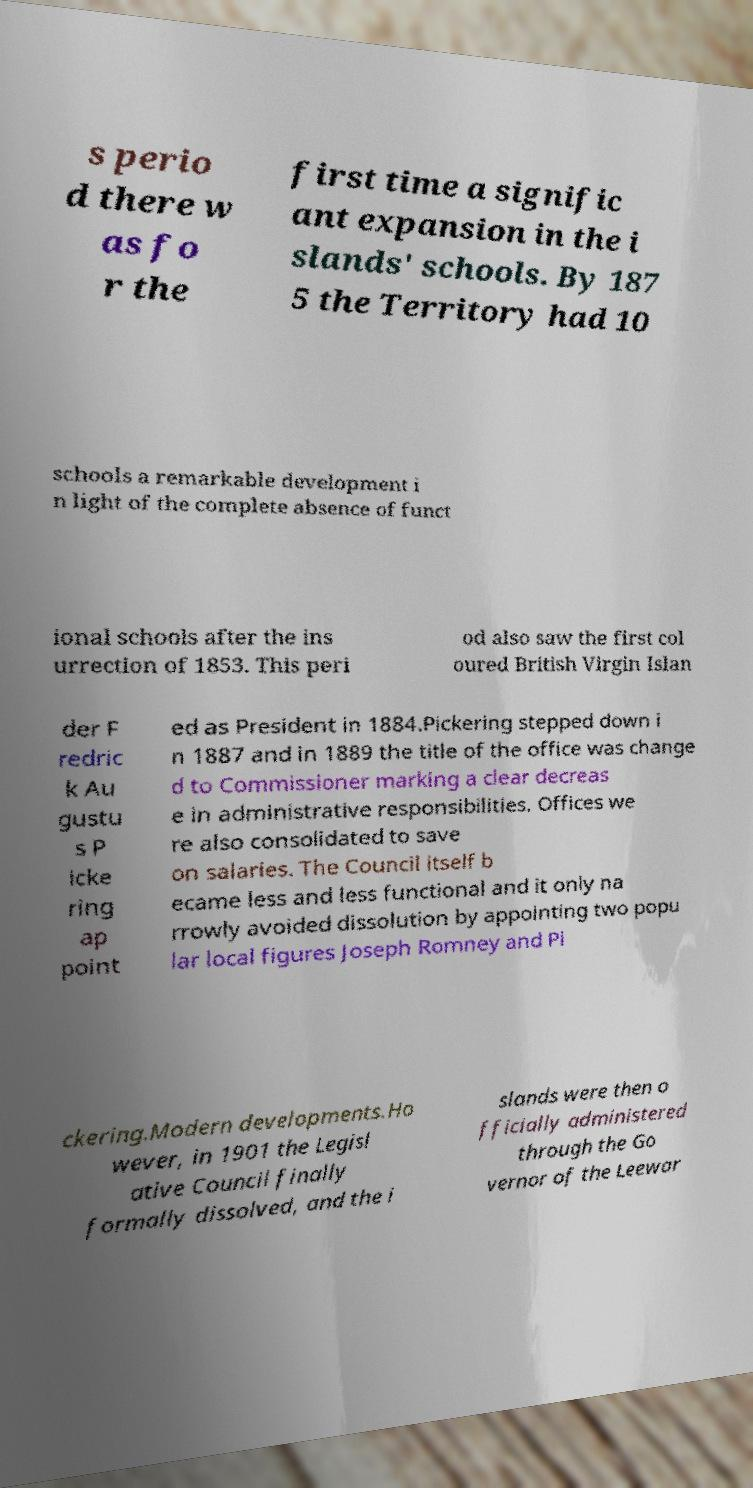What messages or text are displayed in this image? I need them in a readable, typed format. s perio d there w as fo r the first time a signific ant expansion in the i slands' schools. By 187 5 the Territory had 10 schools a remarkable development i n light of the complete absence of funct ional schools after the ins urrection of 1853. This peri od also saw the first col oured British Virgin Islan der F redric k Au gustu s P icke ring ap point ed as President in 1884.Pickering stepped down i n 1887 and in 1889 the title of the office was change d to Commissioner marking a clear decreas e in administrative responsibilities. Offices we re also consolidated to save on salaries. The Council itself b ecame less and less functional and it only na rrowly avoided dissolution by appointing two popu lar local figures Joseph Romney and Pi ckering.Modern developments.Ho wever, in 1901 the Legisl ative Council finally formally dissolved, and the i slands were then o fficially administered through the Go vernor of the Leewar 